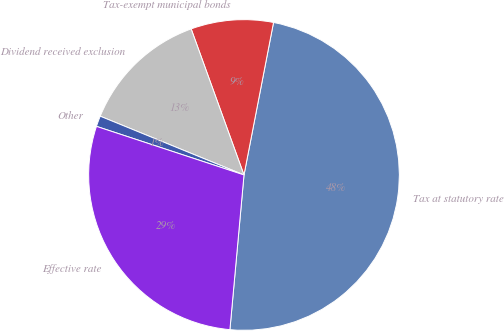Convert chart to OTSL. <chart><loc_0><loc_0><loc_500><loc_500><pie_chart><fcel>Tax at statutory rate<fcel>Tax-exempt municipal bonds<fcel>Dividend received exclusion<fcel>Other<fcel>Effective rate<nl><fcel>48.4%<fcel>8.57%<fcel>13.3%<fcel>1.11%<fcel>28.62%<nl></chart> 